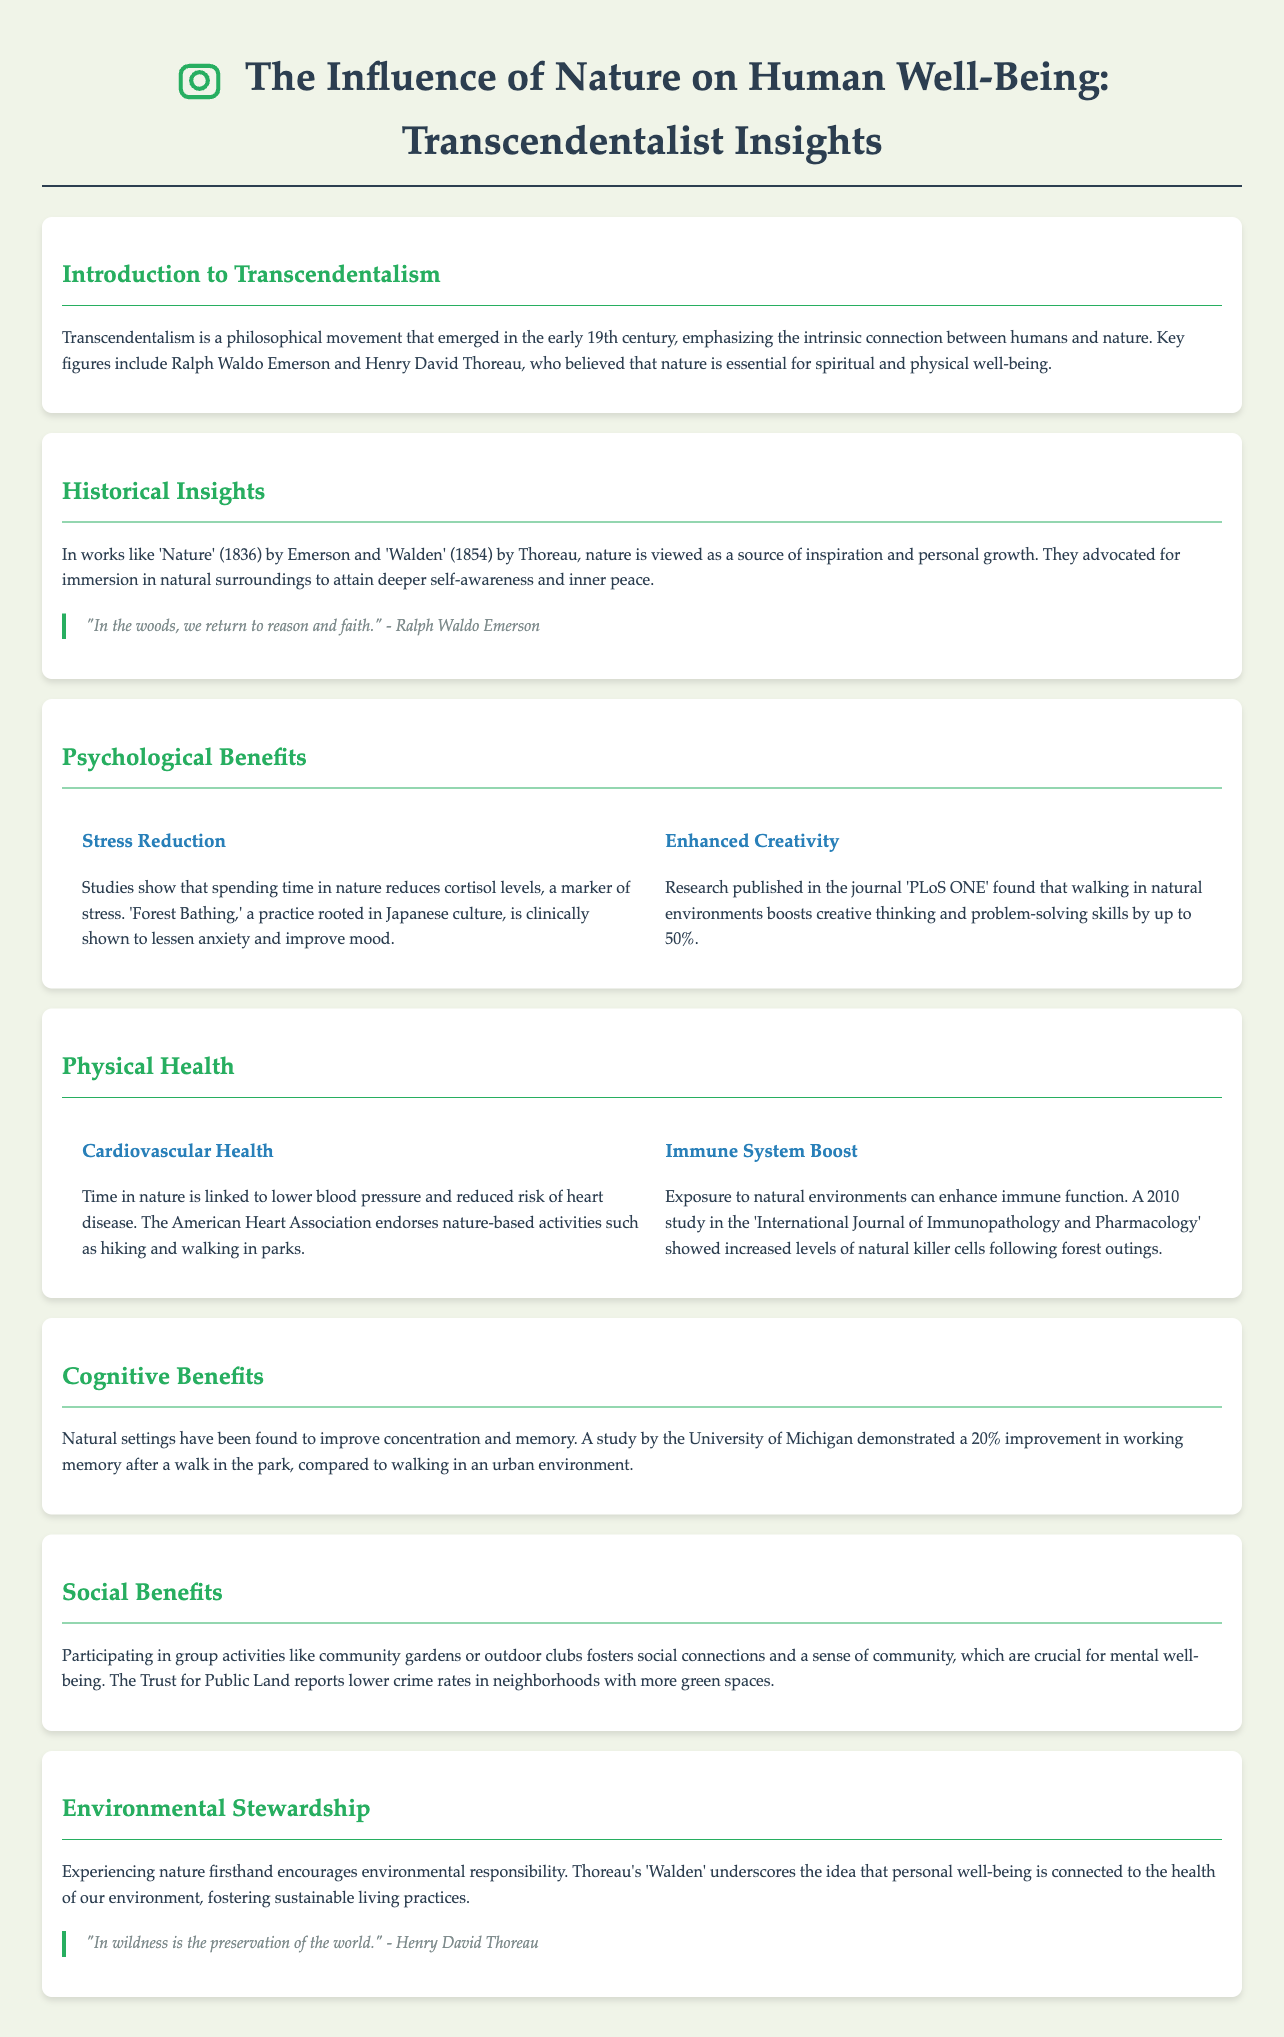What is the primary philosophical movement discussed in the document? The document discusses Transcendentalism, emphasizing the connection between humans and nature.
Answer: Transcendentalism Who wrote 'Walden'? 'Walden' is a work written by Henry David Thoreau, an important figure in Transcendentalism.
Answer: Henry David Thoreau What is one psychological benefit of spending time in nature mentioned in the document? The document states that time in nature reduces cortisol levels, a marker of stress.
Answer: Stress Reduction What percentage of improvement in working memory was noted after walking in nature? A study mentioned in the document showed a 20% improvement in working memory after a walk in the park compared to an urban environment.
Answer: 20% What activity is endorsed by the American Heart Association for cardiovascular health? Nature-based activities such as hiking and walking in parks are endorsed by the American Heart Association.
Answer: Hiking and walking in parks Which author emphasizes that personal well-being is connected to environmental health? The document highlights that Henry David Thoreau underscores the connection between personal well-being and the health of the environment.
Answer: Henry David Thoreau What is one social benefit of engaging in outdoor activities? The document states that participating in group activities fosters social connections and a sense of community, crucial for mental well-being.
Answer: Sense of community What practice is known to enhance immune function according to the document? The document refers to forest outings which can enhance immune function, as detailed in a 2010 study.
Answer: Forest outings Which quote is attributed to Ralph Waldo Emerson in the document? The document includes the quote, "In the woods, we return to reason and faith."
Answer: "In the woods, we return to reason and faith." 